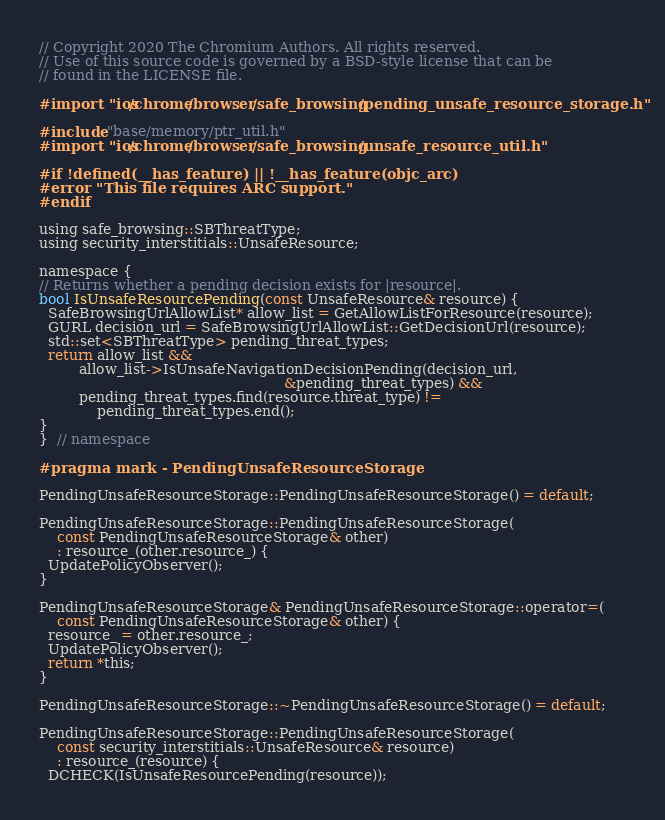<code> <loc_0><loc_0><loc_500><loc_500><_ObjectiveC_>// Copyright 2020 The Chromium Authors. All rights reserved.
// Use of this source code is governed by a BSD-style license that can be
// found in the LICENSE file.

#import "ios/chrome/browser/safe_browsing/pending_unsafe_resource_storage.h"

#include "base/memory/ptr_util.h"
#import "ios/chrome/browser/safe_browsing/unsafe_resource_util.h"

#if !defined(__has_feature) || !__has_feature(objc_arc)
#error "This file requires ARC support."
#endif

using safe_browsing::SBThreatType;
using security_interstitials::UnsafeResource;

namespace {
// Returns whether a pending decision exists for |resource|.
bool IsUnsafeResourcePending(const UnsafeResource& resource) {
  SafeBrowsingUrlAllowList* allow_list = GetAllowListForResource(resource);
  GURL decision_url = SafeBrowsingUrlAllowList::GetDecisionUrl(resource);
  std::set<SBThreatType> pending_threat_types;
  return allow_list &&
         allow_list->IsUnsafeNavigationDecisionPending(decision_url,
                                                       &pending_threat_types) &&
         pending_threat_types.find(resource.threat_type) !=
             pending_threat_types.end();
}
}  // namespace

#pragma mark - PendingUnsafeResourceStorage

PendingUnsafeResourceStorage::PendingUnsafeResourceStorage() = default;

PendingUnsafeResourceStorage::PendingUnsafeResourceStorage(
    const PendingUnsafeResourceStorage& other)
    : resource_(other.resource_) {
  UpdatePolicyObserver();
}

PendingUnsafeResourceStorage& PendingUnsafeResourceStorage::operator=(
    const PendingUnsafeResourceStorage& other) {
  resource_ = other.resource_;
  UpdatePolicyObserver();
  return *this;
}

PendingUnsafeResourceStorage::~PendingUnsafeResourceStorage() = default;

PendingUnsafeResourceStorage::PendingUnsafeResourceStorage(
    const security_interstitials::UnsafeResource& resource)
    : resource_(resource) {
  DCHECK(IsUnsafeResourcePending(resource));</code> 